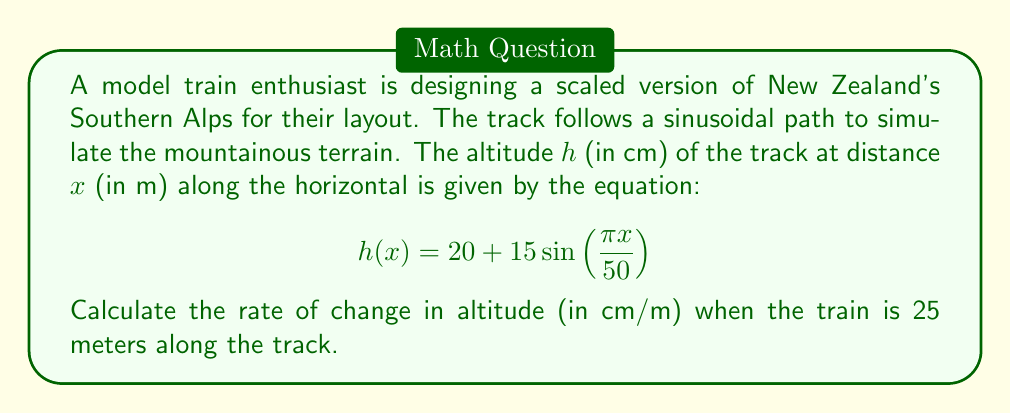Could you help me with this problem? To solve this problem, we need to find the derivative of the altitude function $h(x)$ with respect to $x$, and then evaluate it at $x = 25$ meters.

1. First, let's find the derivative of $h(x)$:
   $$\frac{d}{dx}h(x) = \frac{d}{dx}[20 + 15\sin(\frac{\pi x}{50})]$$
   
   The constant term 20 disappears when we take the derivative, so we focus on the sine term:
   $$\frac{d}{dx}h(x) = 15 \cdot \frac{d}{dx}[\sin(\frac{\pi x}{50})]$$
   
   Using the chain rule, we get:
   $$\frac{d}{dx}h(x) = 15 \cdot \cos(\frac{\pi x}{50}) \cdot \frac{\pi}{50}$$
   
   Simplifying:
   $$\frac{d}{dx}h(x) = \frac{3\pi}{10} \cos(\frac{\pi x}{50})$$

2. Now, we evaluate this derivative at $x = 25$ meters:
   $$\frac{dh}{dx}(25) = \frac{3\pi}{10} \cos(\frac{\pi \cdot 25}{50})$$
   
   $$= \frac{3\pi}{10} \cos(\frac{\pi}{2})$$
   
   $$= \frac{3\pi}{10} \cdot 0 = 0$$

3. The rate of change is 0 cm/m when the train is 25 meters along the track. This makes sense geometrically, as the sine function reaches its maximum at $\frac{\pi}{2}$, which corresponds to a momentary flat section on the track.
Answer: The rate of change in altitude when the train is 25 meters along the track is 0 cm/m. 